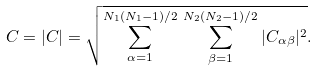Convert formula to latex. <formula><loc_0><loc_0><loc_500><loc_500>C = | { C } | = \sqrt { \sum _ { \alpha = 1 } ^ { N _ { 1 } ( N _ { 1 } - 1 ) / 2 } \, \sum _ { \beta = 1 } ^ { N _ { 2 } ( N _ { 2 } - 1 ) / 2 } | C _ { \alpha \beta } | ^ { 2 } } .</formula> 